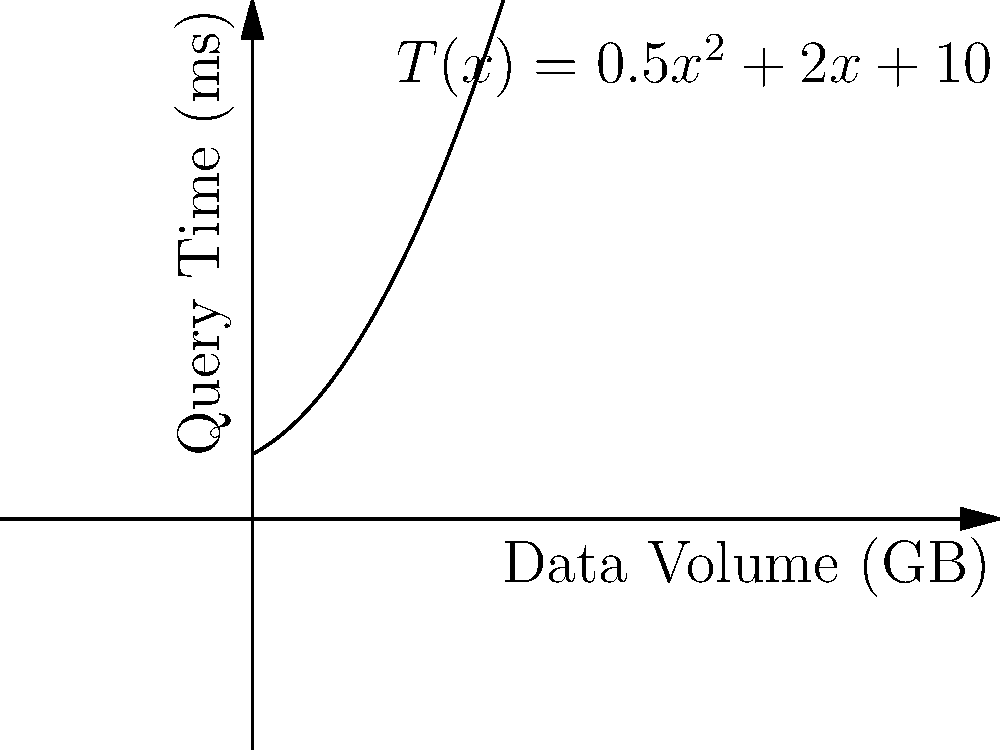A database system's query execution time $T(x)$ (in milliseconds) is modeled by the function $T(x) = 0.5x^2 + 2x + 10$, where $x$ is the data volume in gigabytes. At what rate is the query time changing when the data volume is 5 GB? To find the rate of change of the query time with respect to data volume, we need to calculate the derivative of the function $T(x)$ and evaluate it at $x = 5$.

Step 1: Find the derivative of $T(x)$.
$T(x) = 0.5x^2 + 2x + 10$
$T'(x) = \frac{d}{dx}(0.5x^2 + 2x + 10)$
$T'(x) = 1x + 2$

Step 2: Evaluate $T'(x)$ at $x = 5$.
$T'(5) = 1(5) + 2 = 7$

Therefore, when the data volume is 5 GB, the query time is changing at a rate of 7 ms/GB.
Answer: 7 ms/GB 